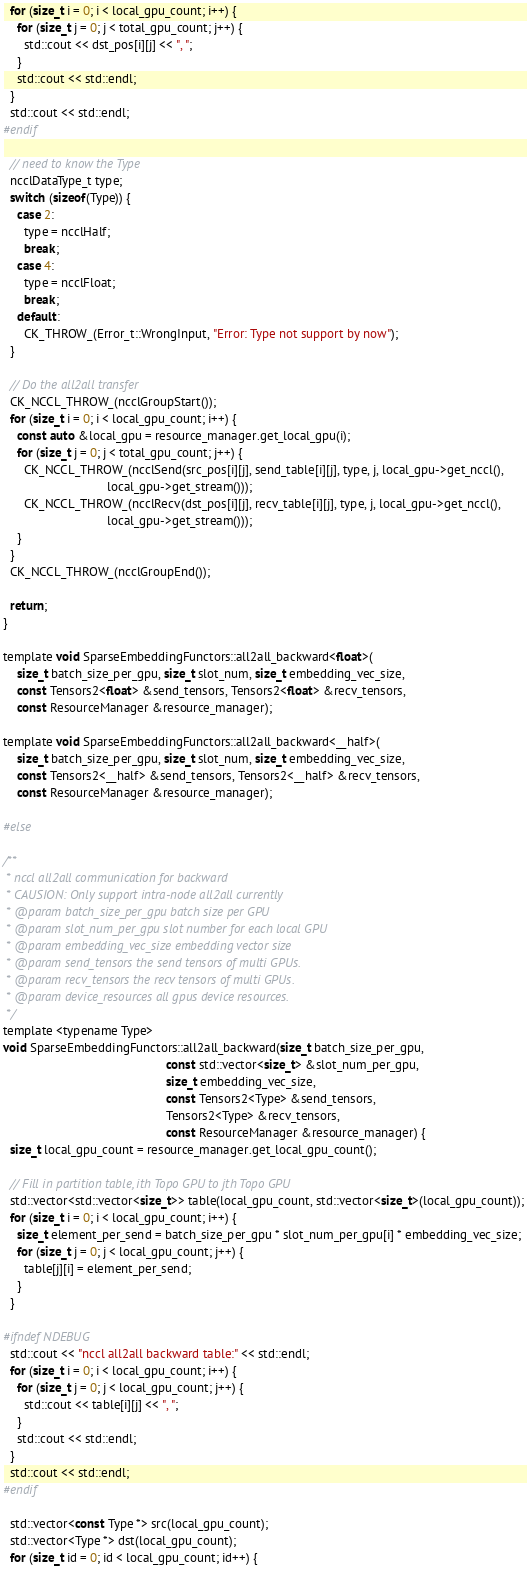<code> <loc_0><loc_0><loc_500><loc_500><_Cuda_>  for (size_t i = 0; i < local_gpu_count; i++) {
    for (size_t j = 0; j < total_gpu_count; j++) {
      std::cout << dst_pos[i][j] << ", ";
    }
    std::cout << std::endl;
  }
  std::cout << std::endl;
#endif

  // need to know the Type
  ncclDataType_t type;
  switch (sizeof(Type)) {
    case 2:
      type = ncclHalf;
      break;
    case 4:
      type = ncclFloat;
      break;
    default:
      CK_THROW_(Error_t::WrongInput, "Error: Type not support by now");
  }

  // Do the all2all transfer
  CK_NCCL_THROW_(ncclGroupStart());
  for (size_t i = 0; i < local_gpu_count; i++) {
    const auto &local_gpu = resource_manager.get_local_gpu(i);
    for (size_t j = 0; j < total_gpu_count; j++) {
      CK_NCCL_THROW_(ncclSend(src_pos[i][j], send_table[i][j], type, j, local_gpu->get_nccl(),
                              local_gpu->get_stream()));
      CK_NCCL_THROW_(ncclRecv(dst_pos[i][j], recv_table[i][j], type, j, local_gpu->get_nccl(),
                              local_gpu->get_stream()));
    }
  }
  CK_NCCL_THROW_(ncclGroupEnd());

  return;
}

template void SparseEmbeddingFunctors::all2all_backward<float>(
    size_t batch_size_per_gpu, size_t slot_num, size_t embedding_vec_size,
    const Tensors2<float> &send_tensors, Tensors2<float> &recv_tensors,
    const ResourceManager &resource_manager);

template void SparseEmbeddingFunctors::all2all_backward<__half>(
    size_t batch_size_per_gpu, size_t slot_num, size_t embedding_vec_size,
    const Tensors2<__half> &send_tensors, Tensors2<__half> &recv_tensors,
    const ResourceManager &resource_manager);

#else

/**
 * nccl all2all communication for backward
 * CAUSION: Only support intra-node all2all currently
 * @param batch_size_per_gpu batch size per GPU
 * @param slot_num_per_gpu slot number for each local GPU
 * @param embedding_vec_size embedding vector size
 * @param send_tensors the send tensors of multi GPUs.
 * @param recv_tensors the recv tensors of multi GPUs.
 * @param device_resources all gpus device resources.
 */
template <typename Type>
void SparseEmbeddingFunctors::all2all_backward(size_t batch_size_per_gpu,
                                               const std::vector<size_t> &slot_num_per_gpu,
                                               size_t embedding_vec_size,
                                               const Tensors2<Type> &send_tensors,
                                               Tensors2<Type> &recv_tensors,
                                               const ResourceManager &resource_manager) {
  size_t local_gpu_count = resource_manager.get_local_gpu_count();

  // Fill in partition table, ith Topo GPU to jth Topo GPU
  std::vector<std::vector<size_t>> table(local_gpu_count, std::vector<size_t>(local_gpu_count));
  for (size_t i = 0; i < local_gpu_count; i++) {
    size_t element_per_send = batch_size_per_gpu * slot_num_per_gpu[i] * embedding_vec_size;
    for (size_t j = 0; j < local_gpu_count; j++) {
      table[j][i] = element_per_send;
    }
  }

#ifndef NDEBUG
  std::cout << "nccl all2all backward table:" << std::endl;
  for (size_t i = 0; i < local_gpu_count; i++) {
    for (size_t j = 0; j < local_gpu_count; j++) {
      std::cout << table[i][j] << ", ";
    }
    std::cout << std::endl;
  }
  std::cout << std::endl;
#endif

  std::vector<const Type *> src(local_gpu_count);
  std::vector<Type *> dst(local_gpu_count);
  for (size_t id = 0; id < local_gpu_count; id++) {</code> 